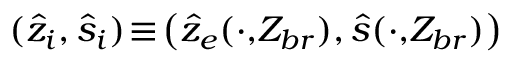<formula> <loc_0><loc_0><loc_500><loc_500>( \hat { z } _ { i } , \hat { s } _ { i } ) \, \equiv \, \left ( \hat { z } _ { e } ( \cdot , \, Z _ { b r } ) , \hat { s } ( \cdot , \, Z _ { b r } ) \right )</formula> 